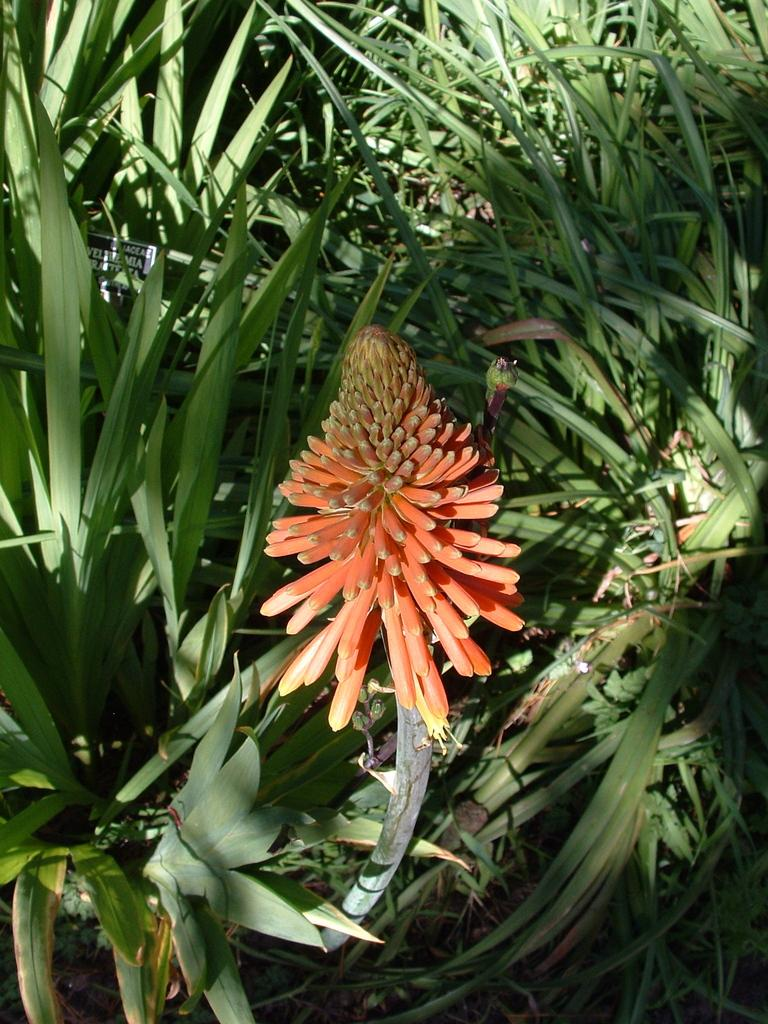What is the main subject in the foreground of the image? There is an orange flower in the foreground of the image. What is the orange flower a part of? The orange flower is part of a plant. What can be seen in the background of the image? There are plants visible in the background of the image. Can you see someone kicking the orange flower in the image? No, there is no person or action of kicking present in the image. 